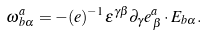<formula> <loc_0><loc_0><loc_500><loc_500>\omega ^ { a } _ { \, b \alpha } = - ( e ) ^ { - 1 } \epsilon ^ { \gamma \beta } \partial _ { \gamma } e ^ { a } _ { \, \beta } \cdot E _ { b \alpha } .</formula> 